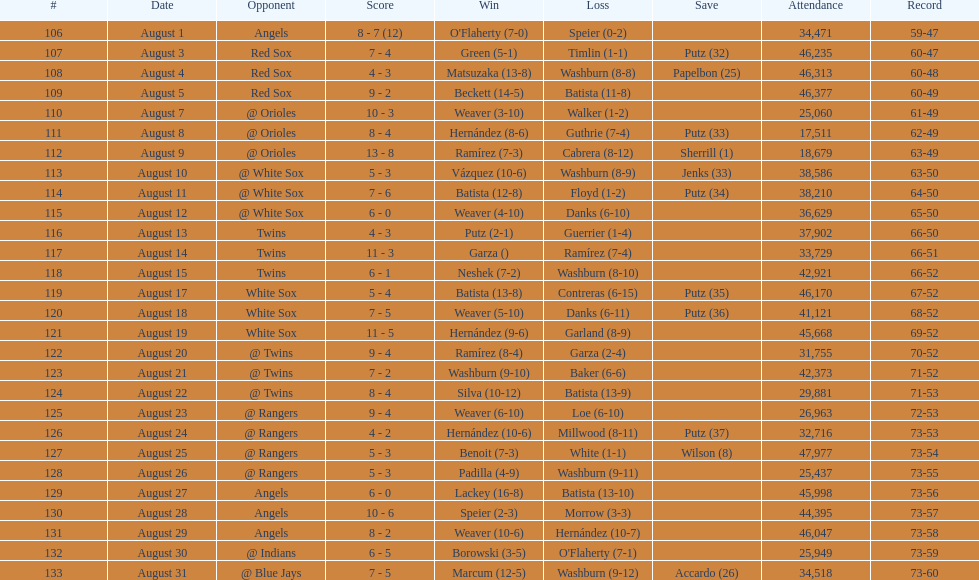How many victories were achieved during this period? 5. 